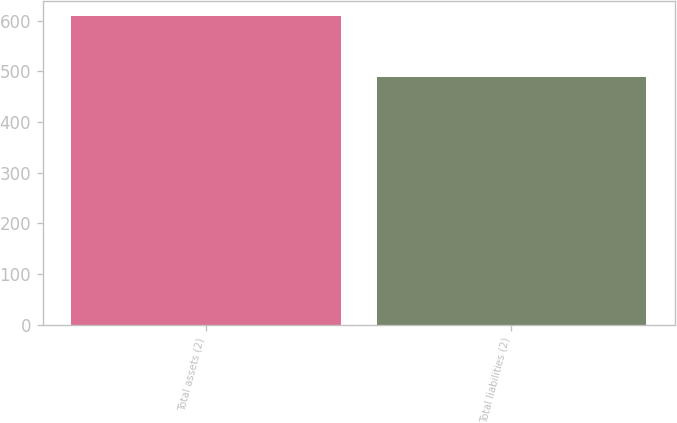<chart> <loc_0><loc_0><loc_500><loc_500><bar_chart><fcel>Total assets (2)<fcel>Total liabilities (2)<nl><fcel>608<fcel>488<nl></chart> 